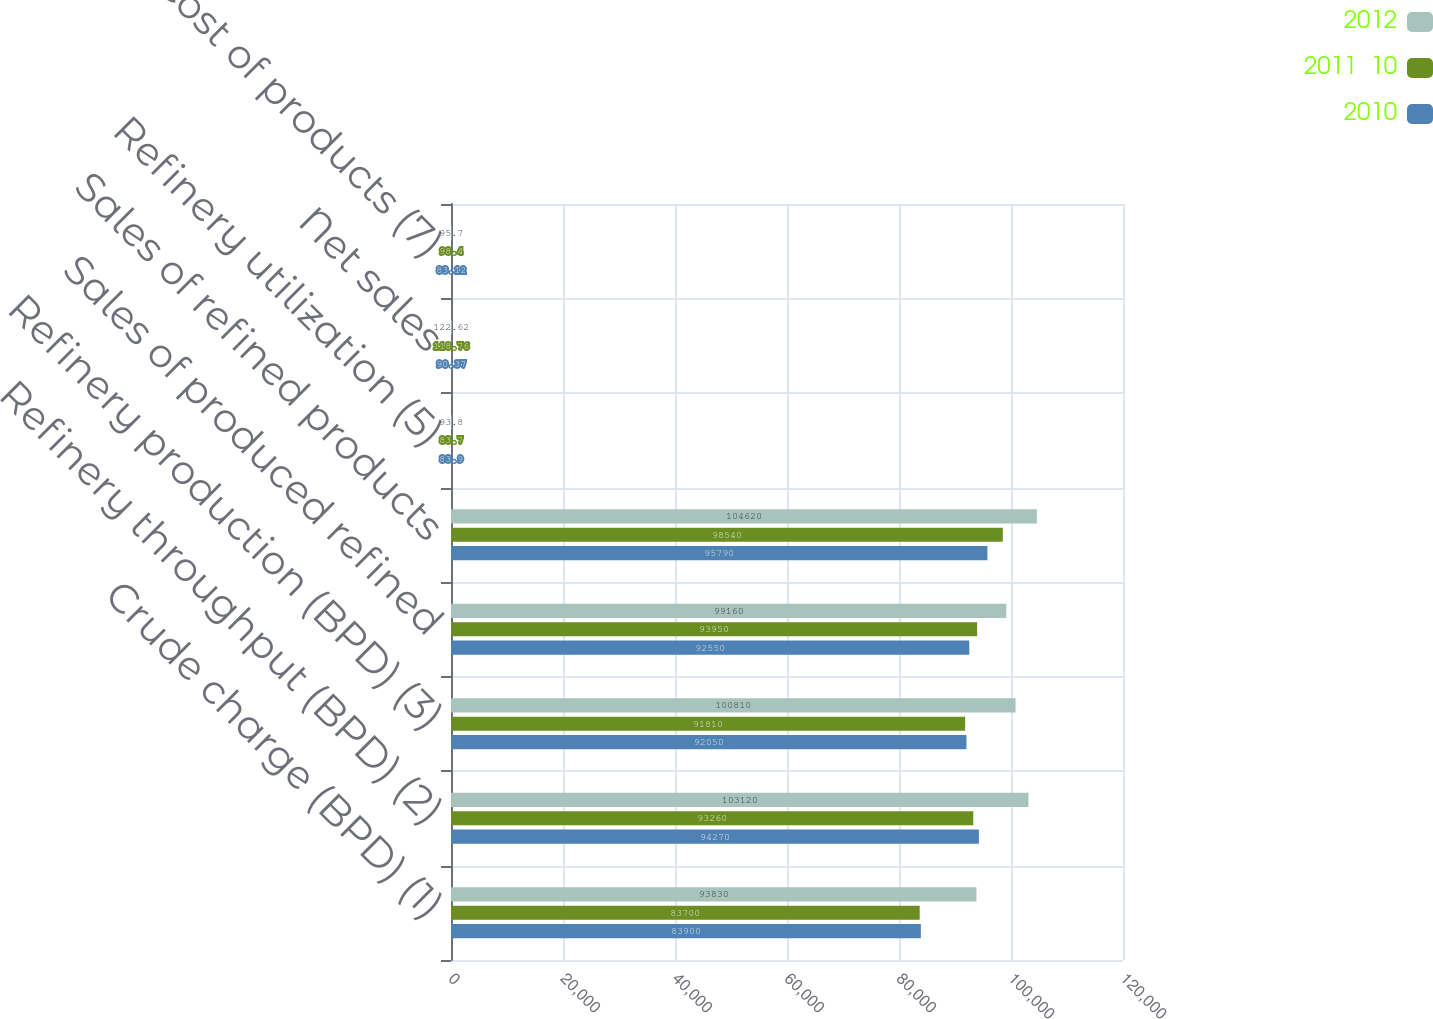Convert chart. <chart><loc_0><loc_0><loc_500><loc_500><stacked_bar_chart><ecel><fcel>Crude charge (BPD) (1)<fcel>Refinery throughput (BPD) (2)<fcel>Refinery production (BPD) (3)<fcel>Sales of produced refined<fcel>Sales of refined products<fcel>Refinery utilization (5)<fcel>Net sales<fcel>Cost of products (7)<nl><fcel>2012<fcel>93830<fcel>103120<fcel>100810<fcel>99160<fcel>104620<fcel>93.8<fcel>122.62<fcel>95.7<nl><fcel>2011  10<fcel>83700<fcel>93260<fcel>91810<fcel>93950<fcel>98540<fcel>83.7<fcel>118.76<fcel>98.4<nl><fcel>2010<fcel>83900<fcel>94270<fcel>92050<fcel>92550<fcel>95790<fcel>83.9<fcel>90.37<fcel>83.12<nl></chart> 